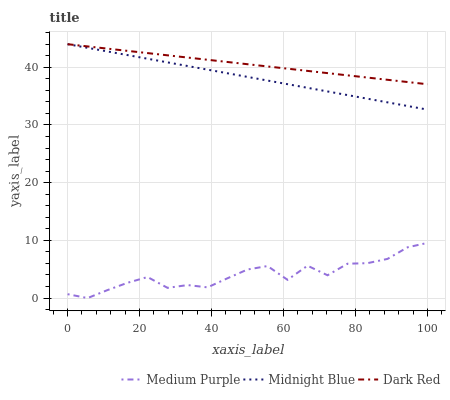Does Medium Purple have the minimum area under the curve?
Answer yes or no. Yes. Does Dark Red have the maximum area under the curve?
Answer yes or no. Yes. Does Midnight Blue have the minimum area under the curve?
Answer yes or no. No. Does Midnight Blue have the maximum area under the curve?
Answer yes or no. No. Is Midnight Blue the smoothest?
Answer yes or no. Yes. Is Medium Purple the roughest?
Answer yes or no. Yes. Is Dark Red the smoothest?
Answer yes or no. No. Is Dark Red the roughest?
Answer yes or no. No. Does Medium Purple have the lowest value?
Answer yes or no. Yes. Does Midnight Blue have the lowest value?
Answer yes or no. No. Does Midnight Blue have the highest value?
Answer yes or no. Yes. Is Medium Purple less than Dark Red?
Answer yes or no. Yes. Is Dark Red greater than Medium Purple?
Answer yes or no. Yes. Does Midnight Blue intersect Dark Red?
Answer yes or no. Yes. Is Midnight Blue less than Dark Red?
Answer yes or no. No. Is Midnight Blue greater than Dark Red?
Answer yes or no. No. Does Medium Purple intersect Dark Red?
Answer yes or no. No. 